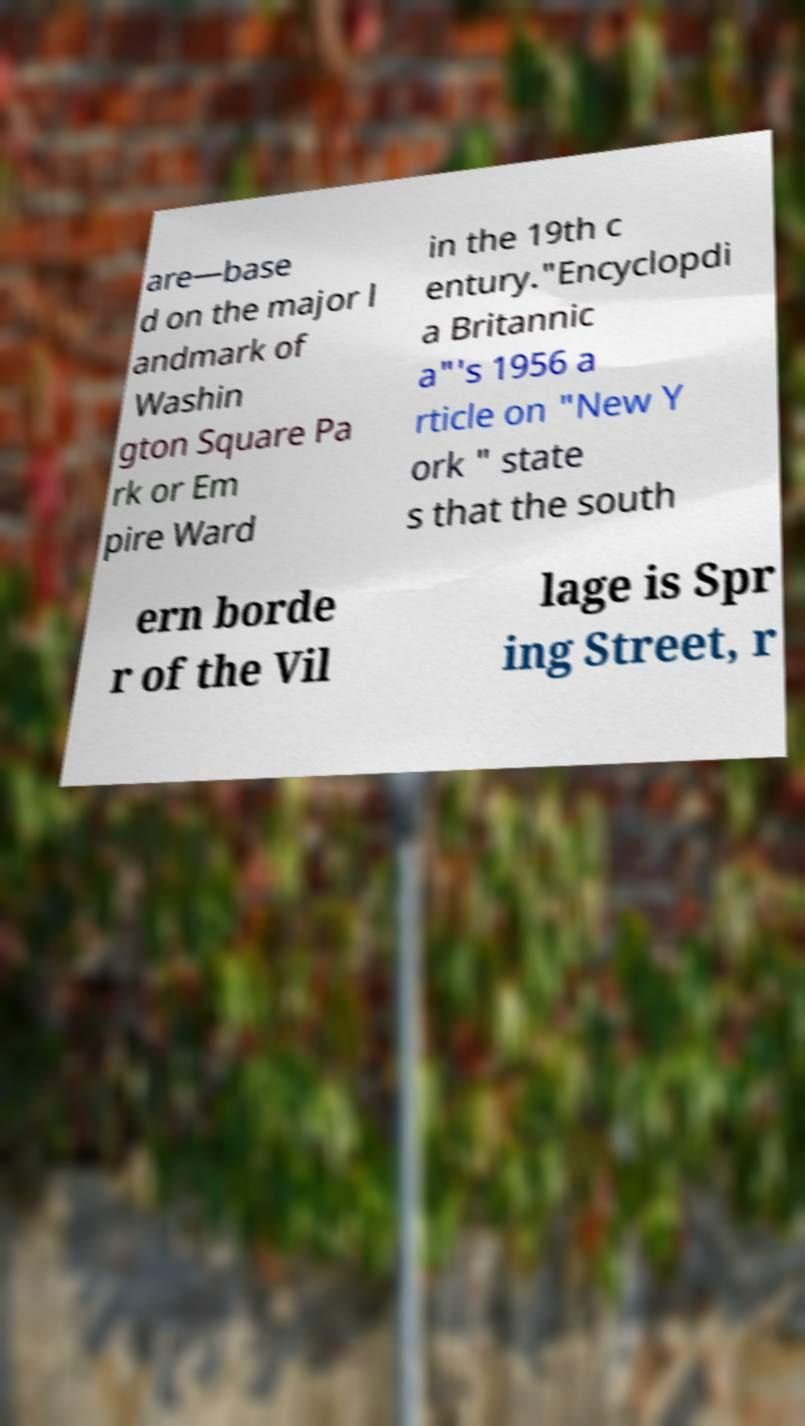Could you assist in decoding the text presented in this image and type it out clearly? are—base d on the major l andmark of Washin gton Square Pa rk or Em pire Ward in the 19th c entury."Encyclopdi a Britannic a"'s 1956 a rticle on "New Y ork " state s that the south ern borde r of the Vil lage is Spr ing Street, r 